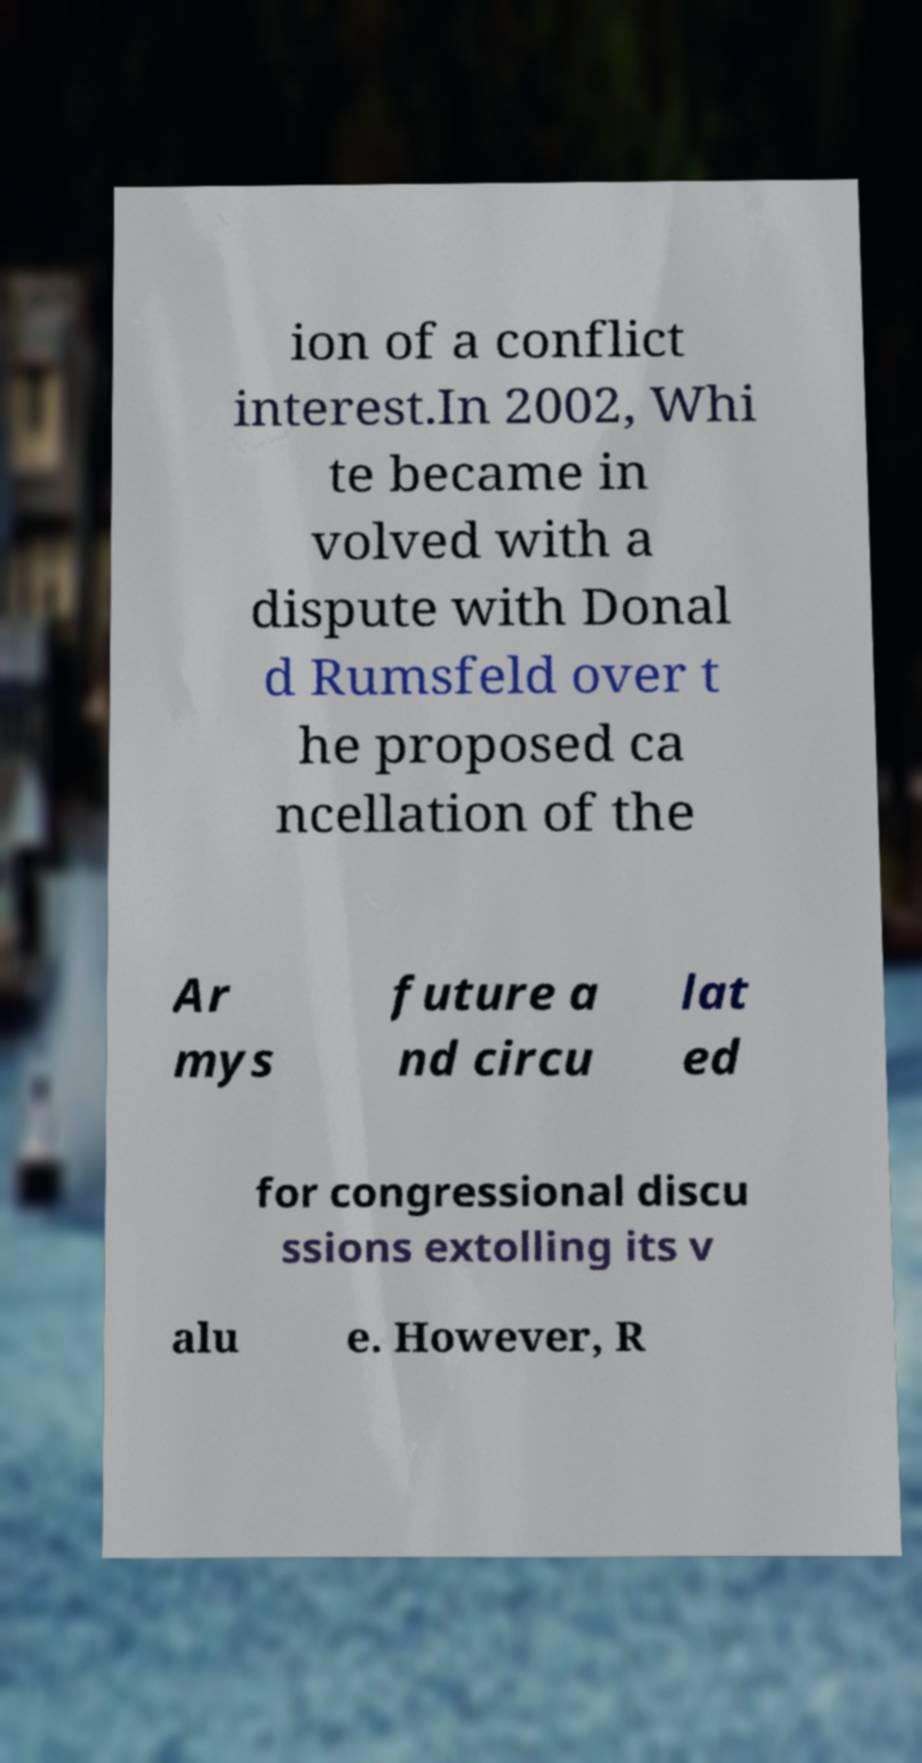There's text embedded in this image that I need extracted. Can you transcribe it verbatim? ion of a conflict interest.In 2002, Whi te became in volved with a dispute with Donal d Rumsfeld over t he proposed ca ncellation of the Ar mys future a nd circu lat ed for congressional discu ssions extolling its v alu e. However, R 